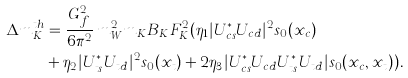<formula> <loc_0><loc_0><loc_500><loc_500>\Delta m ^ { t h } _ { K } & = \frac { G ^ { 2 } _ { f } } { 6 \pi ^ { 2 } } \, m ^ { 2 } _ { W } m _ { K } B _ { K } F ^ { 2 } _ { K } ( \eta _ { 1 } | U ^ { * } _ { c s } U _ { c d } | ^ { 2 } s _ { 0 } ( x _ { c } ) \\ & + \eta _ { 2 } | U ^ { * } _ { t s } U _ { t d } | ^ { 2 } s _ { 0 } ( x _ { t } ) + 2 \eta _ { 3 } | U ^ { * } _ { c s } U _ { c d } U ^ { * } _ { t s } U _ { t d } | s _ { 0 } ( x _ { c } , x _ { t } ) ) .</formula> 